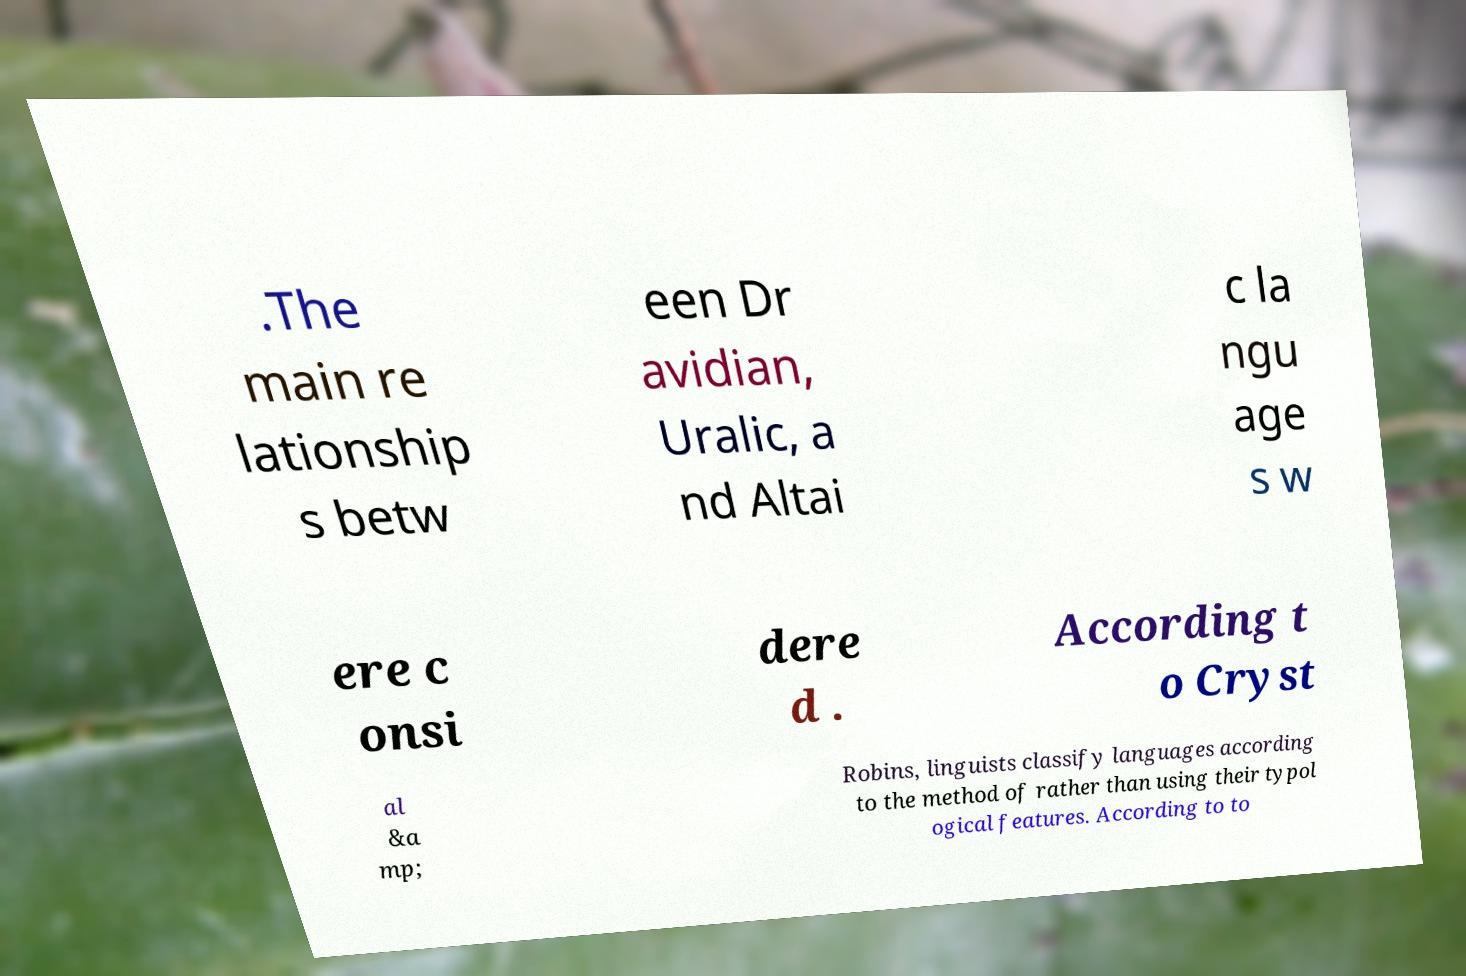Please identify and transcribe the text found in this image. .The main re lationship s betw een Dr avidian, Uralic, a nd Altai c la ngu age s w ere c onsi dere d . According t o Cryst al &a mp; Robins, linguists classify languages according to the method of rather than using their typol ogical features. According to to 